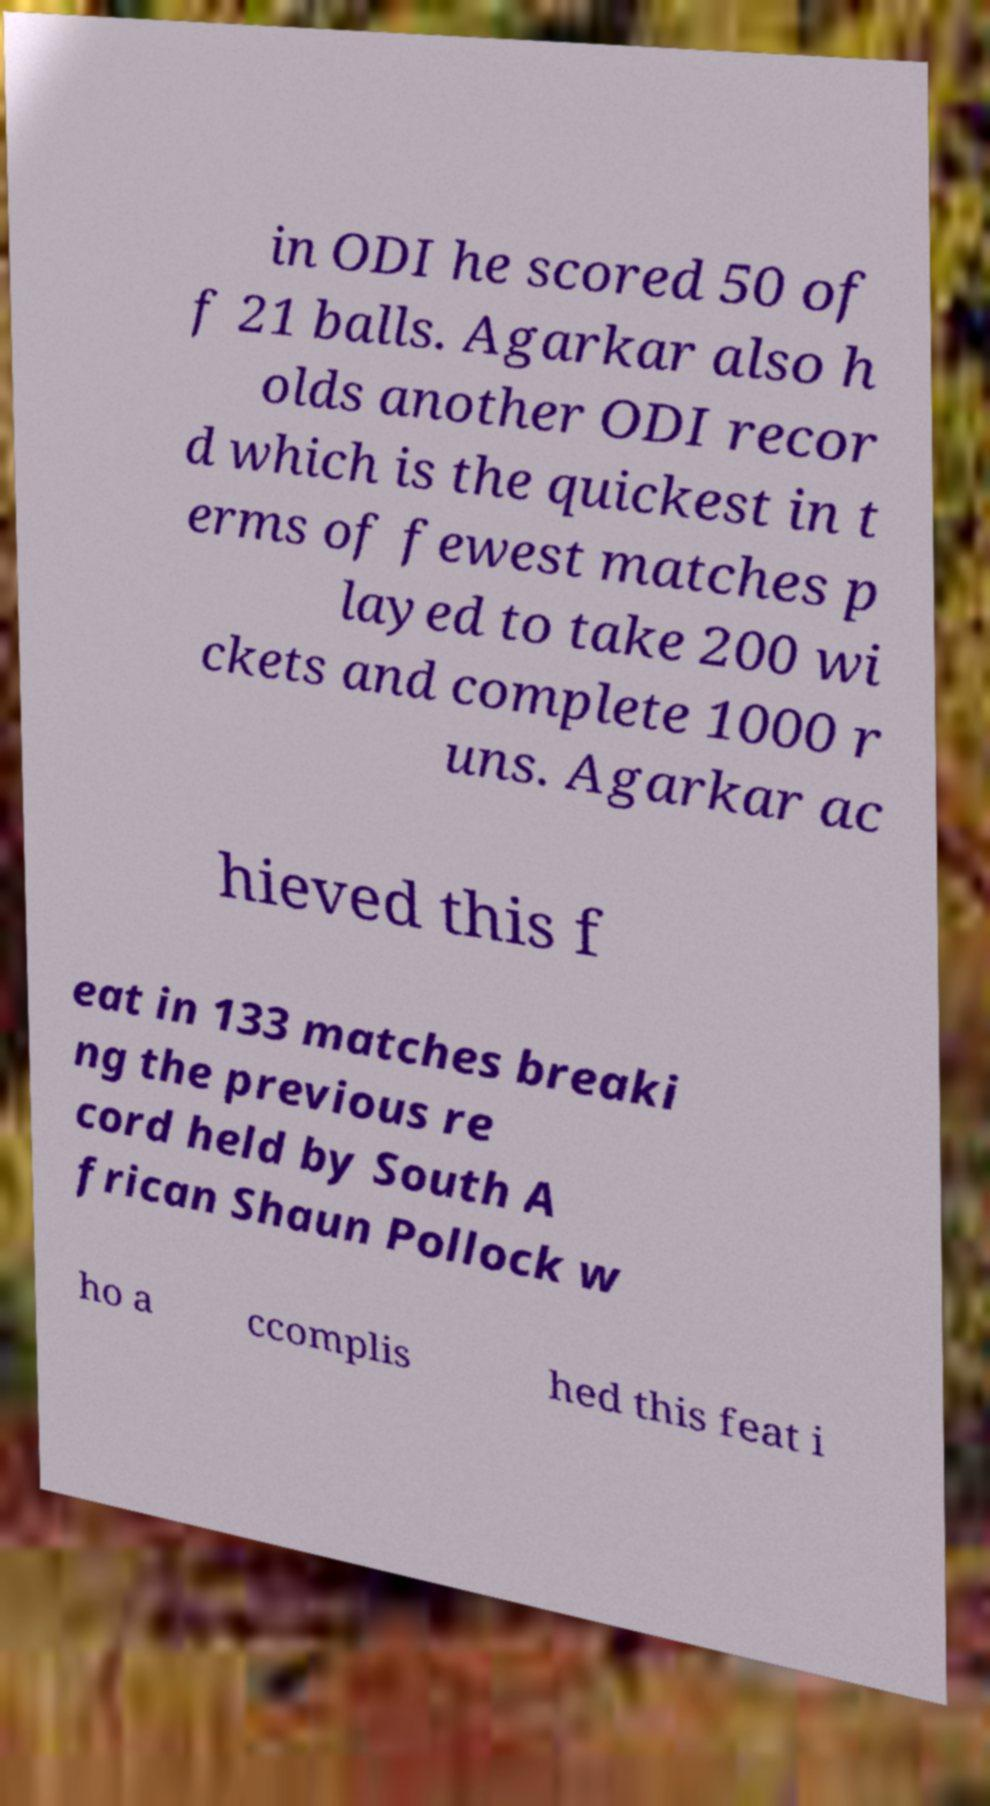Can you read and provide the text displayed in the image?This photo seems to have some interesting text. Can you extract and type it out for me? in ODI he scored 50 of f 21 balls. Agarkar also h olds another ODI recor d which is the quickest in t erms of fewest matches p layed to take 200 wi ckets and complete 1000 r uns. Agarkar ac hieved this f eat in 133 matches breaki ng the previous re cord held by South A frican Shaun Pollock w ho a ccomplis hed this feat i 